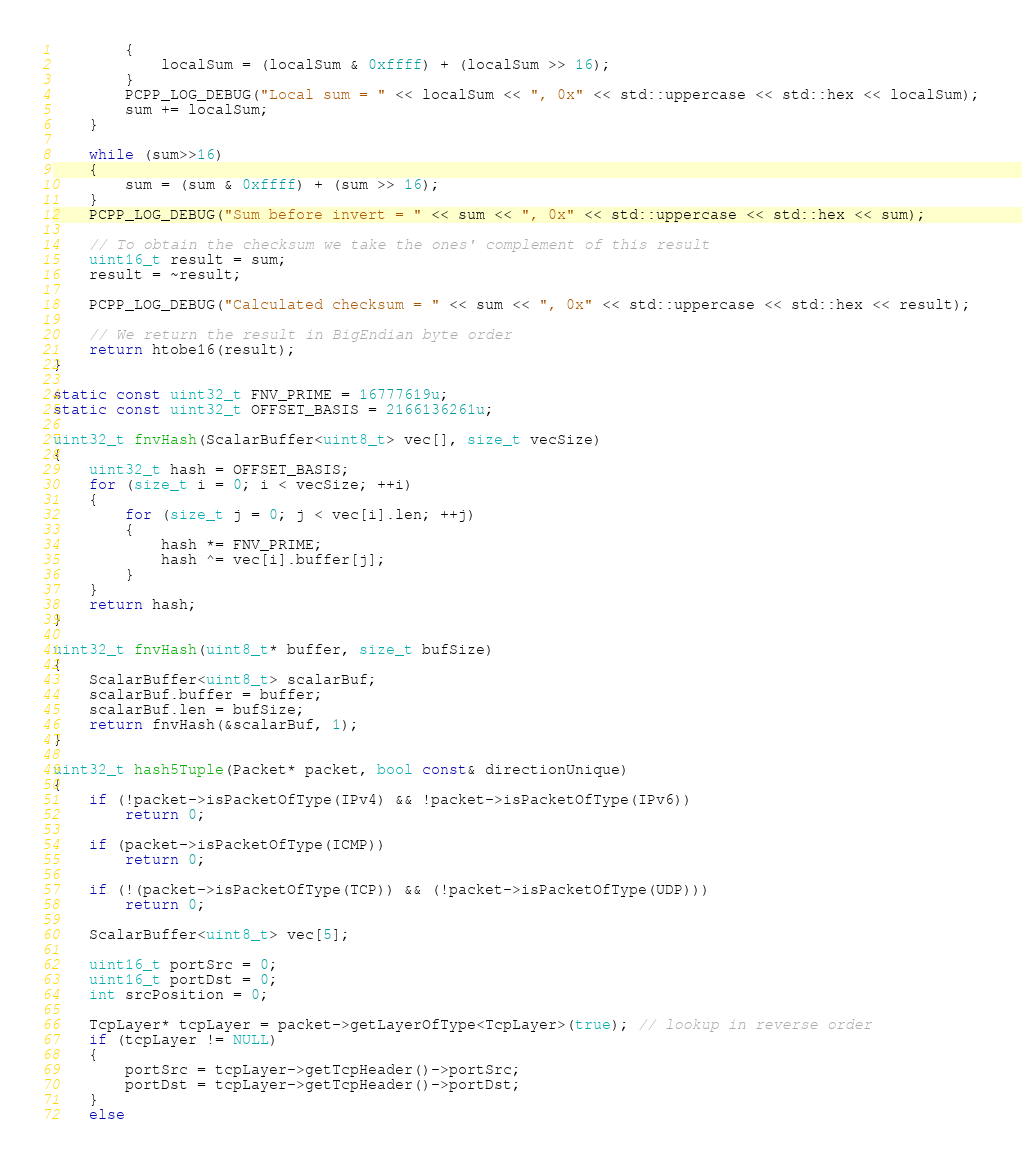Convert code to text. <code><loc_0><loc_0><loc_500><loc_500><_C++_>		{
			localSum = (localSum & 0xffff) + (localSum >> 16);
		}
		PCPP_LOG_DEBUG("Local sum = " << localSum << ", 0x" << std::uppercase << std::hex << localSum);
		sum += localSum;
	}

	while (sum>>16)
	{
		sum = (sum & 0xffff) + (sum >> 16);
	}
	PCPP_LOG_DEBUG("Sum before invert = " << sum << ", 0x" << std::uppercase << std::hex << sum);

	// To obtain the checksum we take the ones' complement of this result
	uint16_t result = sum;
	result = ~result;

	PCPP_LOG_DEBUG("Calculated checksum = " << sum << ", 0x" << std::uppercase << std::hex << result);

	// We return the result in BigEndian byte order
	return htobe16(result);
}

static const uint32_t FNV_PRIME = 16777619u;
static const uint32_t OFFSET_BASIS = 2166136261u;

uint32_t fnvHash(ScalarBuffer<uint8_t> vec[], size_t vecSize)
{
	uint32_t hash = OFFSET_BASIS;
	for (size_t i = 0; i < vecSize; ++i)
	{
		for (size_t j = 0; j < vec[i].len; ++j)
		{
			hash *= FNV_PRIME;
			hash ^= vec[i].buffer[j];
		}
	}
	return hash;
}

uint32_t fnvHash(uint8_t* buffer, size_t bufSize)
{
	ScalarBuffer<uint8_t> scalarBuf;
	scalarBuf.buffer = buffer;
	scalarBuf.len = bufSize;
	return fnvHash(&scalarBuf, 1);
}

uint32_t hash5Tuple(Packet* packet, bool const& directionUnique)
{
	if (!packet->isPacketOfType(IPv4) && !packet->isPacketOfType(IPv6))
		return 0;

	if (packet->isPacketOfType(ICMP))
		return 0;

	if (!(packet->isPacketOfType(TCP)) && (!packet->isPacketOfType(UDP)))
		return 0;

	ScalarBuffer<uint8_t> vec[5];

	uint16_t portSrc = 0;
	uint16_t portDst = 0;
	int srcPosition = 0;

	TcpLayer* tcpLayer = packet->getLayerOfType<TcpLayer>(true); // lookup in reverse order
	if (tcpLayer != NULL)
	{
		portSrc = tcpLayer->getTcpHeader()->portSrc;
		portDst = tcpLayer->getTcpHeader()->portDst;
	}
	else</code> 